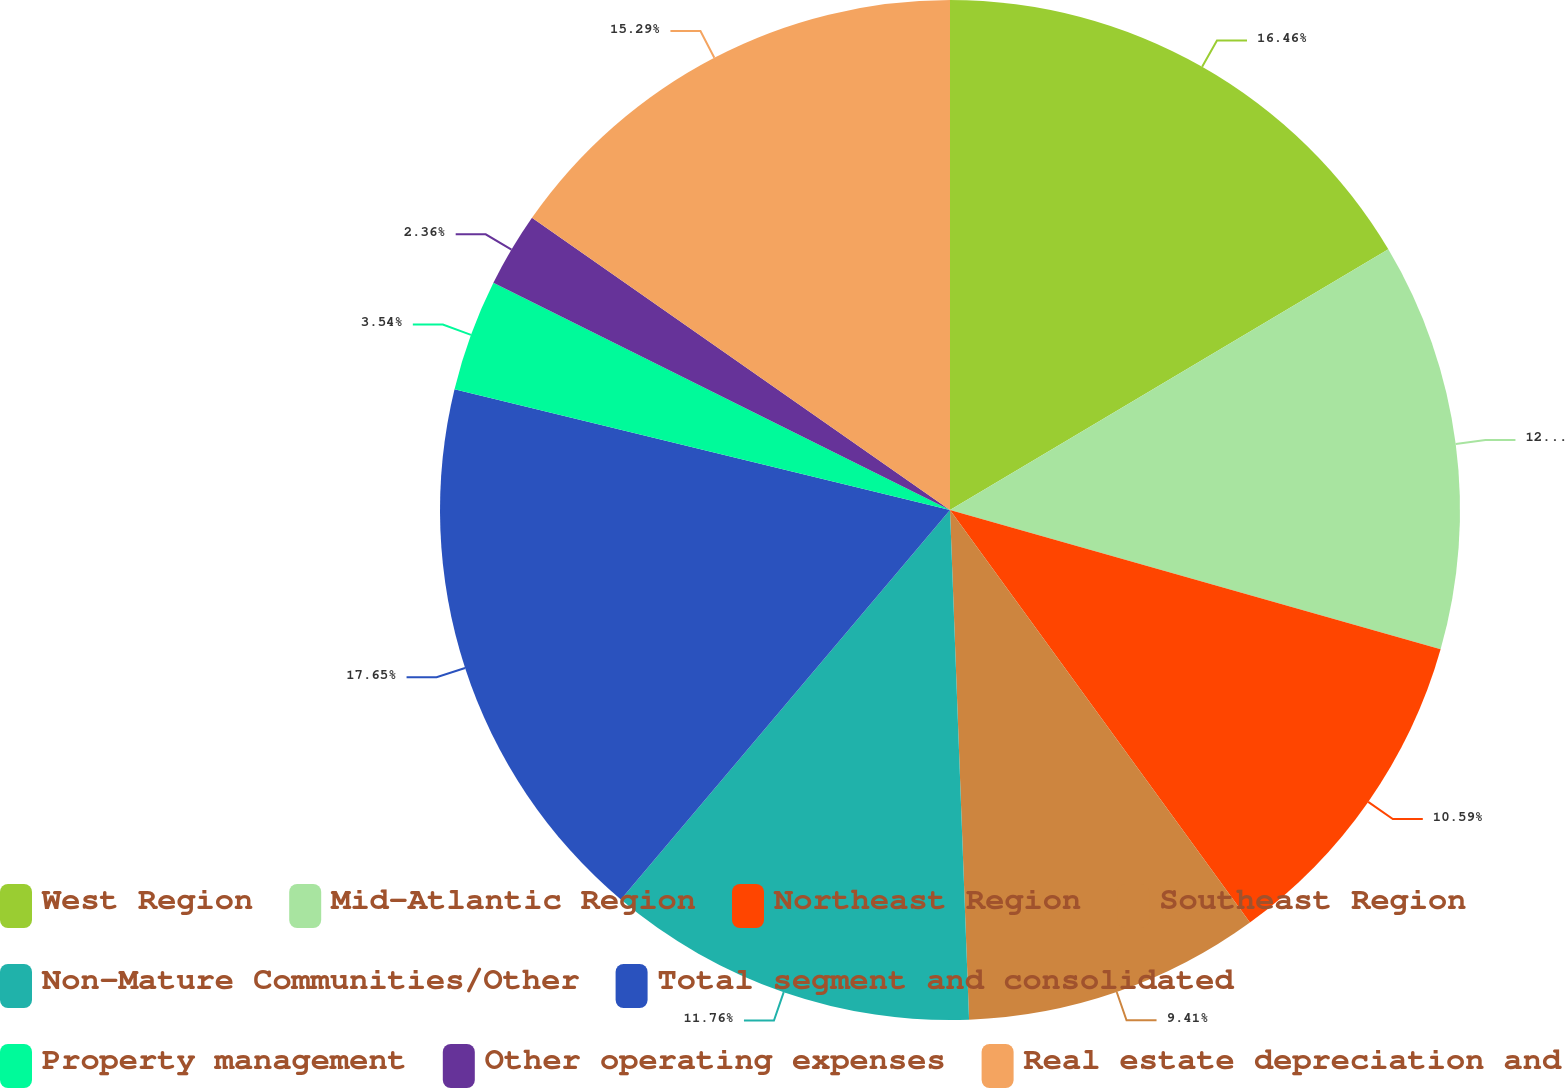Convert chart. <chart><loc_0><loc_0><loc_500><loc_500><pie_chart><fcel>West Region<fcel>Mid-Atlantic Region<fcel>Northeast Region<fcel>Southeast Region<fcel>Non-Mature Communities/Other<fcel>Total segment and consolidated<fcel>Property management<fcel>Other operating expenses<fcel>Real estate depreciation and<nl><fcel>16.46%<fcel>12.94%<fcel>10.59%<fcel>9.41%<fcel>11.76%<fcel>17.64%<fcel>3.54%<fcel>2.36%<fcel>15.29%<nl></chart> 